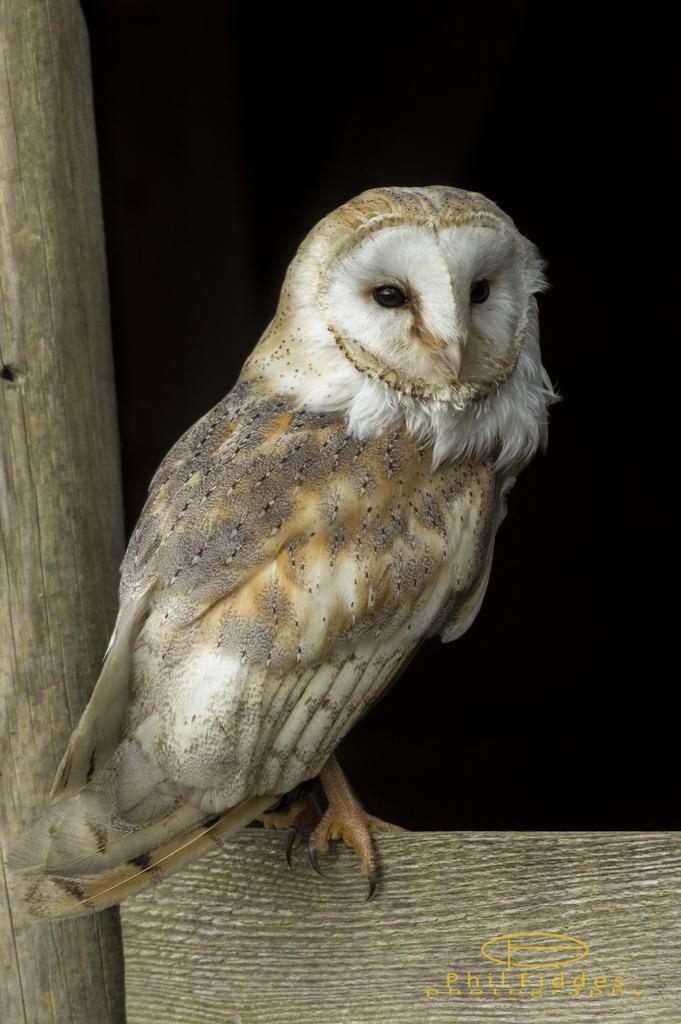Please provide a concise description of this image. In this image we can see an owl on an object. On the left side there is a wooden object. In the background it is dark. In the right bottom corner there is a watermark. 